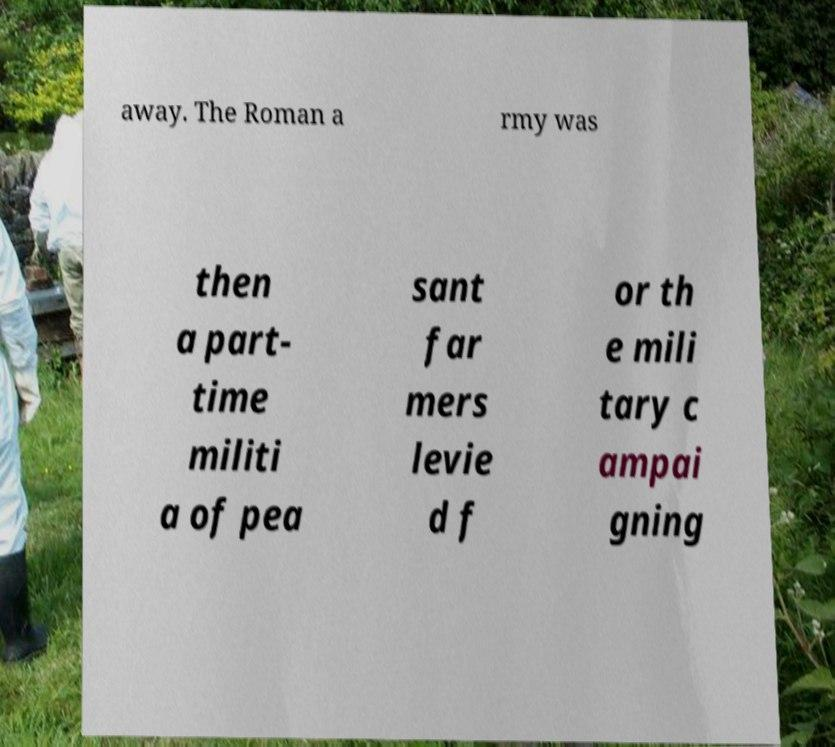Please identify and transcribe the text found in this image. away. The Roman a rmy was then a part- time militi a of pea sant far mers levie d f or th e mili tary c ampai gning 